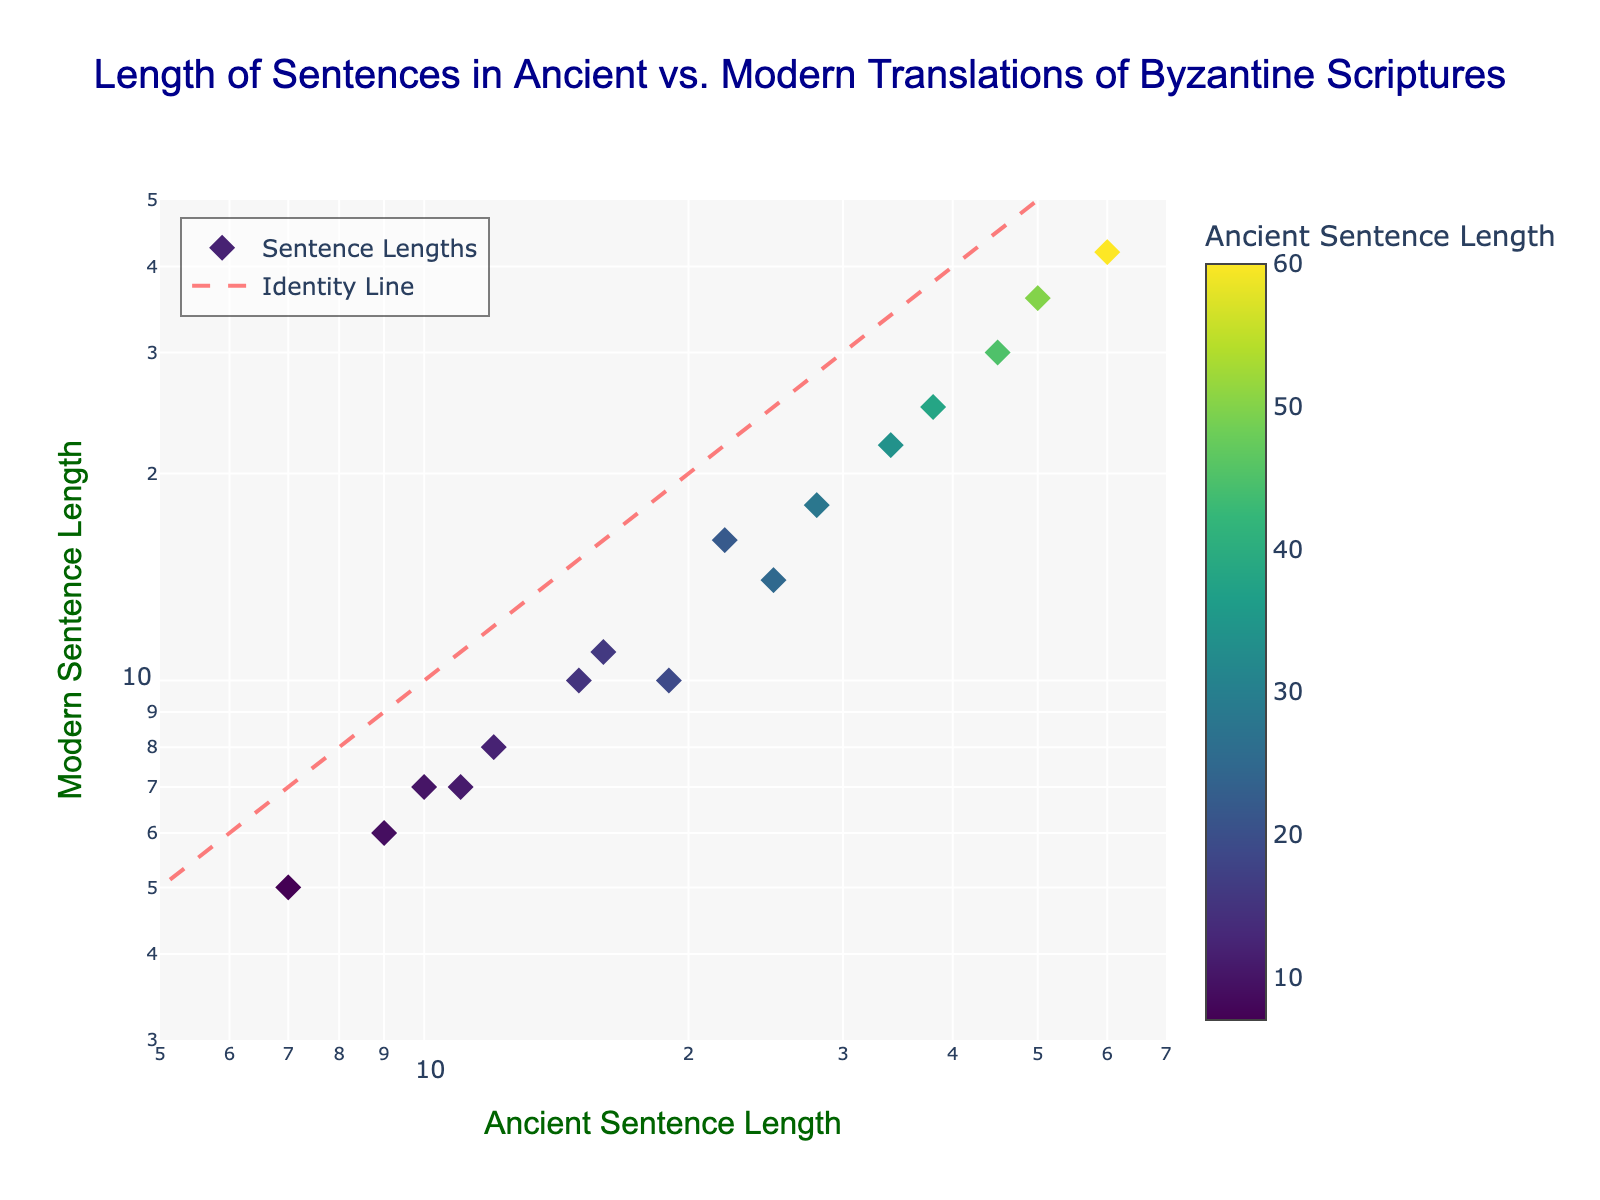What is the title of the figure? The title is usually displayed at the top of a figure. In this case, it is "Length of Sentences in Ancient vs. Modern Translations of Byzantine Scriptures".
Answer: Length of Sentences in Ancient vs. Modern Translations of Byzantine Scriptures Which axis represents the ancient sentence lengths? The x-axis represents the ancient sentence lengths as indicated by the label "Ancient Sentence Length".
Answer: x-axis What is the color scheme used for the markers? The markers use a Viridis colorscale which ranges from dark blue to yellow.
Answer: Viridis How many data points are represented in the scatter plot? By counting the markers, we see that there are 16 data points in the plot.
Answer: 16 What is the visible trend between ancient and modern sentence lengths in general? The trend can be observed by looking at how the data points cluster. Most data points are below the identity line, suggesting ancient sentences are generally longer than their modern counterparts.
Answer: Ancient sentences are generally longer Which sentence length (ancient or modern) varies more across the dataset? The variability can be judged by the range of values on the respective axes. The ancient sentence length ranges from 7 to 60, whereas the modern sentence length ranges from 5 to 42, indicating more variability in ancient sentence lengths.
Answer: Ancient sentence lengths vary more Is there any sentence pair where the ancient sentence length is equal to the modern one? Check if there is any data point on the identity line. In this case, there are no markers lying exactly on the red dashed identity line.
Answer: No What is the difference in length between the longest ancient sentence and its modern translation? The longest ancient sentence is 60 and its modern translation is 42. The difference is calculated as 60 - 42 = 18.
Answer: 18 What is the ratio of the length of the shortest ancient sentence to its modern translation? The shortest ancient sentence is 7 and its modern counterpart is 5. The ratio is 7/5.
Answer: 1.4 Which pair has the highest ratio of ancient to modern sentence length? Calculate the ratio for each pair: e.g. 12/8, 25/14, etc. The pair (60,42) has the highest ratio of approximately 1.43.
Answer: (60, 42) How does the data compare with the identity line in terms of their locations? Most data points fall below the identity line which signifies that for the same lengths, ancient sentences are longer compared to modern ones as they plot below y = x.
Answer: Below the identity line 